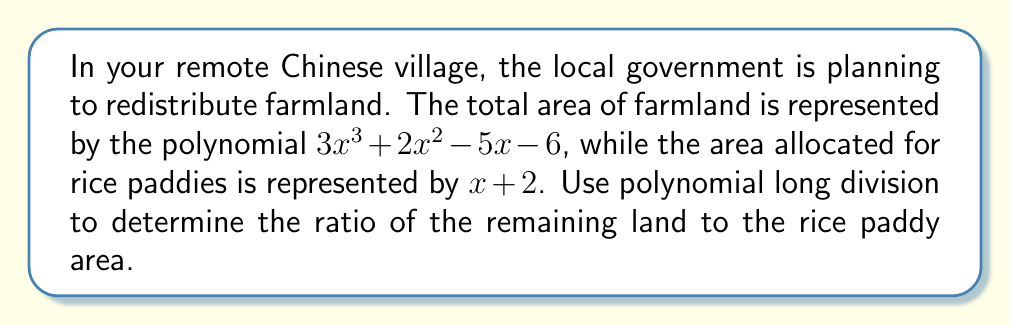Could you help me with this problem? Let's approach this step-by-step using polynomial long division:

1) Set up the division:
   $$\frac{3x^3 + 2x^2 - 5x - 6}{x + 2}$$

2) Divide $3x^3$ by $x$:
   $$3x^2$$
   Multiply $(x + 2)$ by $3x^2$: $3x^3 + 6x^2$
   Subtract: $3x^3 + 2x^2 - 5x - 6 - (3x^3 + 6x^2) = -4x^2 - 5x - 6$

3) Bring down all terms and divide $-4x^2$ by $x$:
   $$3x^2 - 4x$$
   Multiply $(x + 2)$ by $-4x$: $-4x^2 - 8x$
   Subtract: $-4x^2 - 5x - 6 - (-4x^2 - 8x) = 3x - 6$

4) Bring down all terms and divide $3x$ by $x$:
   $$3x^2 - 4x + 3$$
   Multiply $(x + 2)$ by $3$: $3x + 6$
   Subtract: $3x - 6 - (3x + 6) = -12$

5) The division is complete. We have:
   $$3x^3 + 2x^2 - 5x - 6 = (x + 2)(3x^2 - 4x + 3) - 12$$

6) The quotient $3x^2 - 4x + 3$ represents the ratio of the remaining land to the rice paddy area.
Answer: $3x^2 - 4x + 3$ 